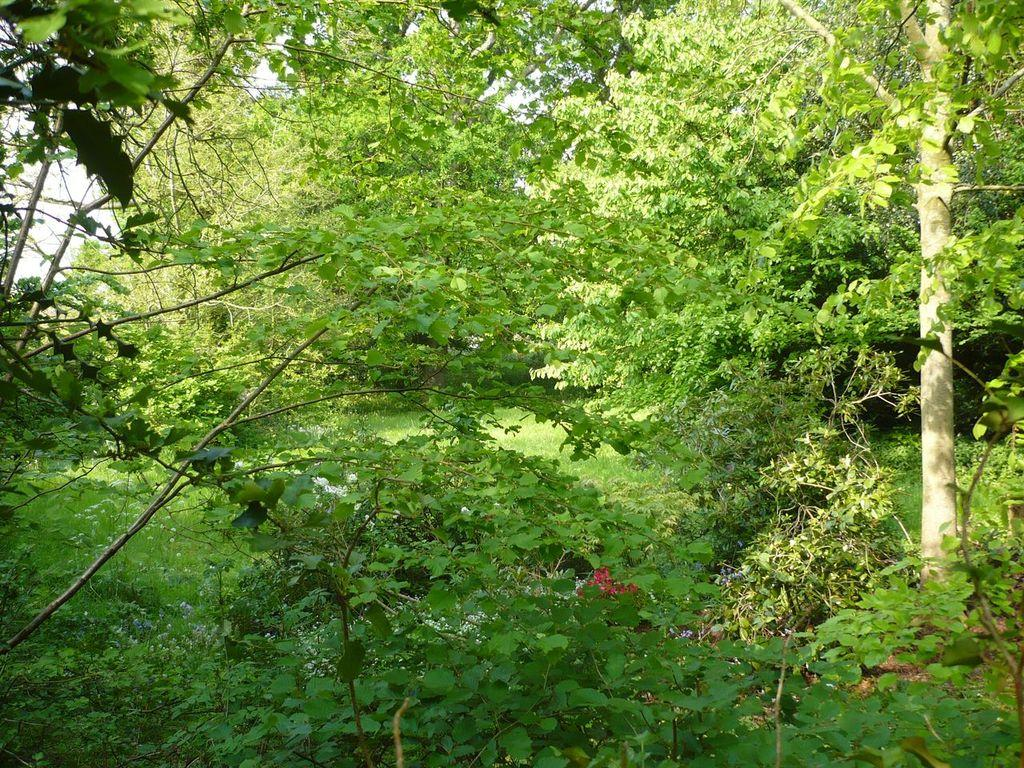What type of environment is depicted in the image? The image features greenery, suggesting a natural or outdoor setting. What type of agreement is being discussed in the image? There is no discussion or agreement present in the image; it features greenery. How does the greenery affect the person's throat in the image? There is no person or throat present in the image; it only features greenery. 